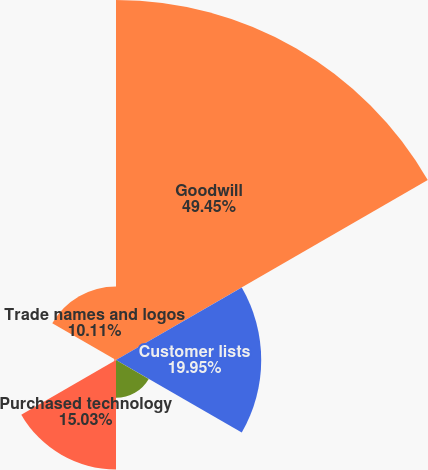<chart> <loc_0><loc_0><loc_500><loc_500><pie_chart><fcel>Goodwill<fcel>Customer lists<fcel>Covenants not to compete<fcel>Purchased technology<fcel>Assembled workforce<fcel>Trade names and logos<nl><fcel>49.46%<fcel>19.95%<fcel>5.19%<fcel>15.03%<fcel>0.27%<fcel>10.11%<nl></chart> 